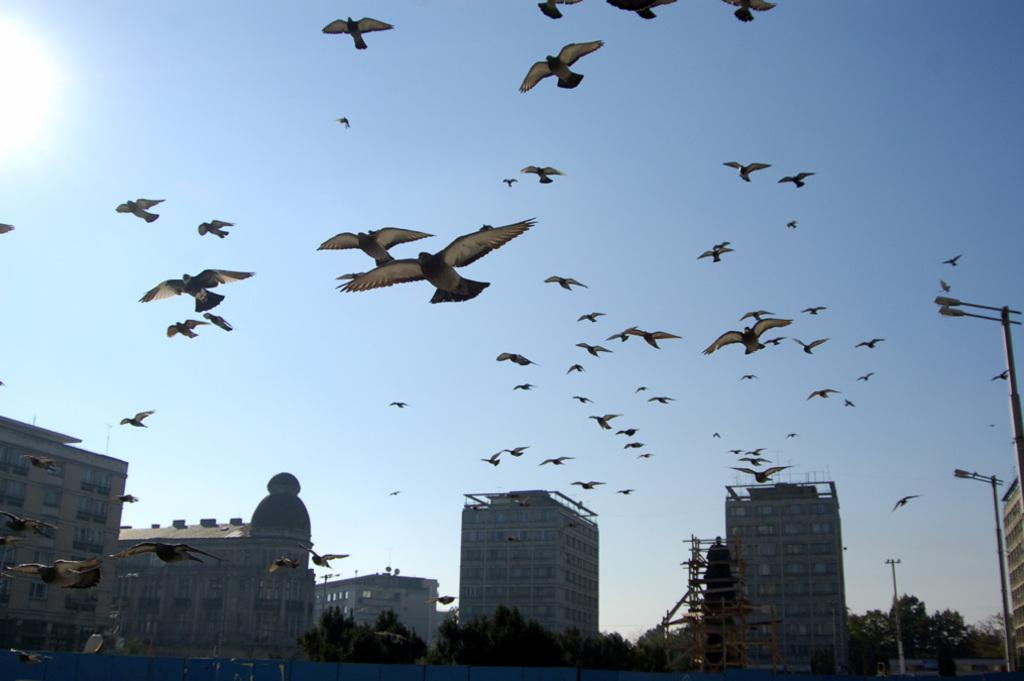What is happening in the sky in the image? There are birds flying in the air in the image. What can be seen in the distance behind the birds? There are buildings and trees in the background of the image. How many jellyfish can be seen swimming in the water in the image? There are no jellyfish or water present in the image; it features birds flying in the air with buildings and trees in the background. 